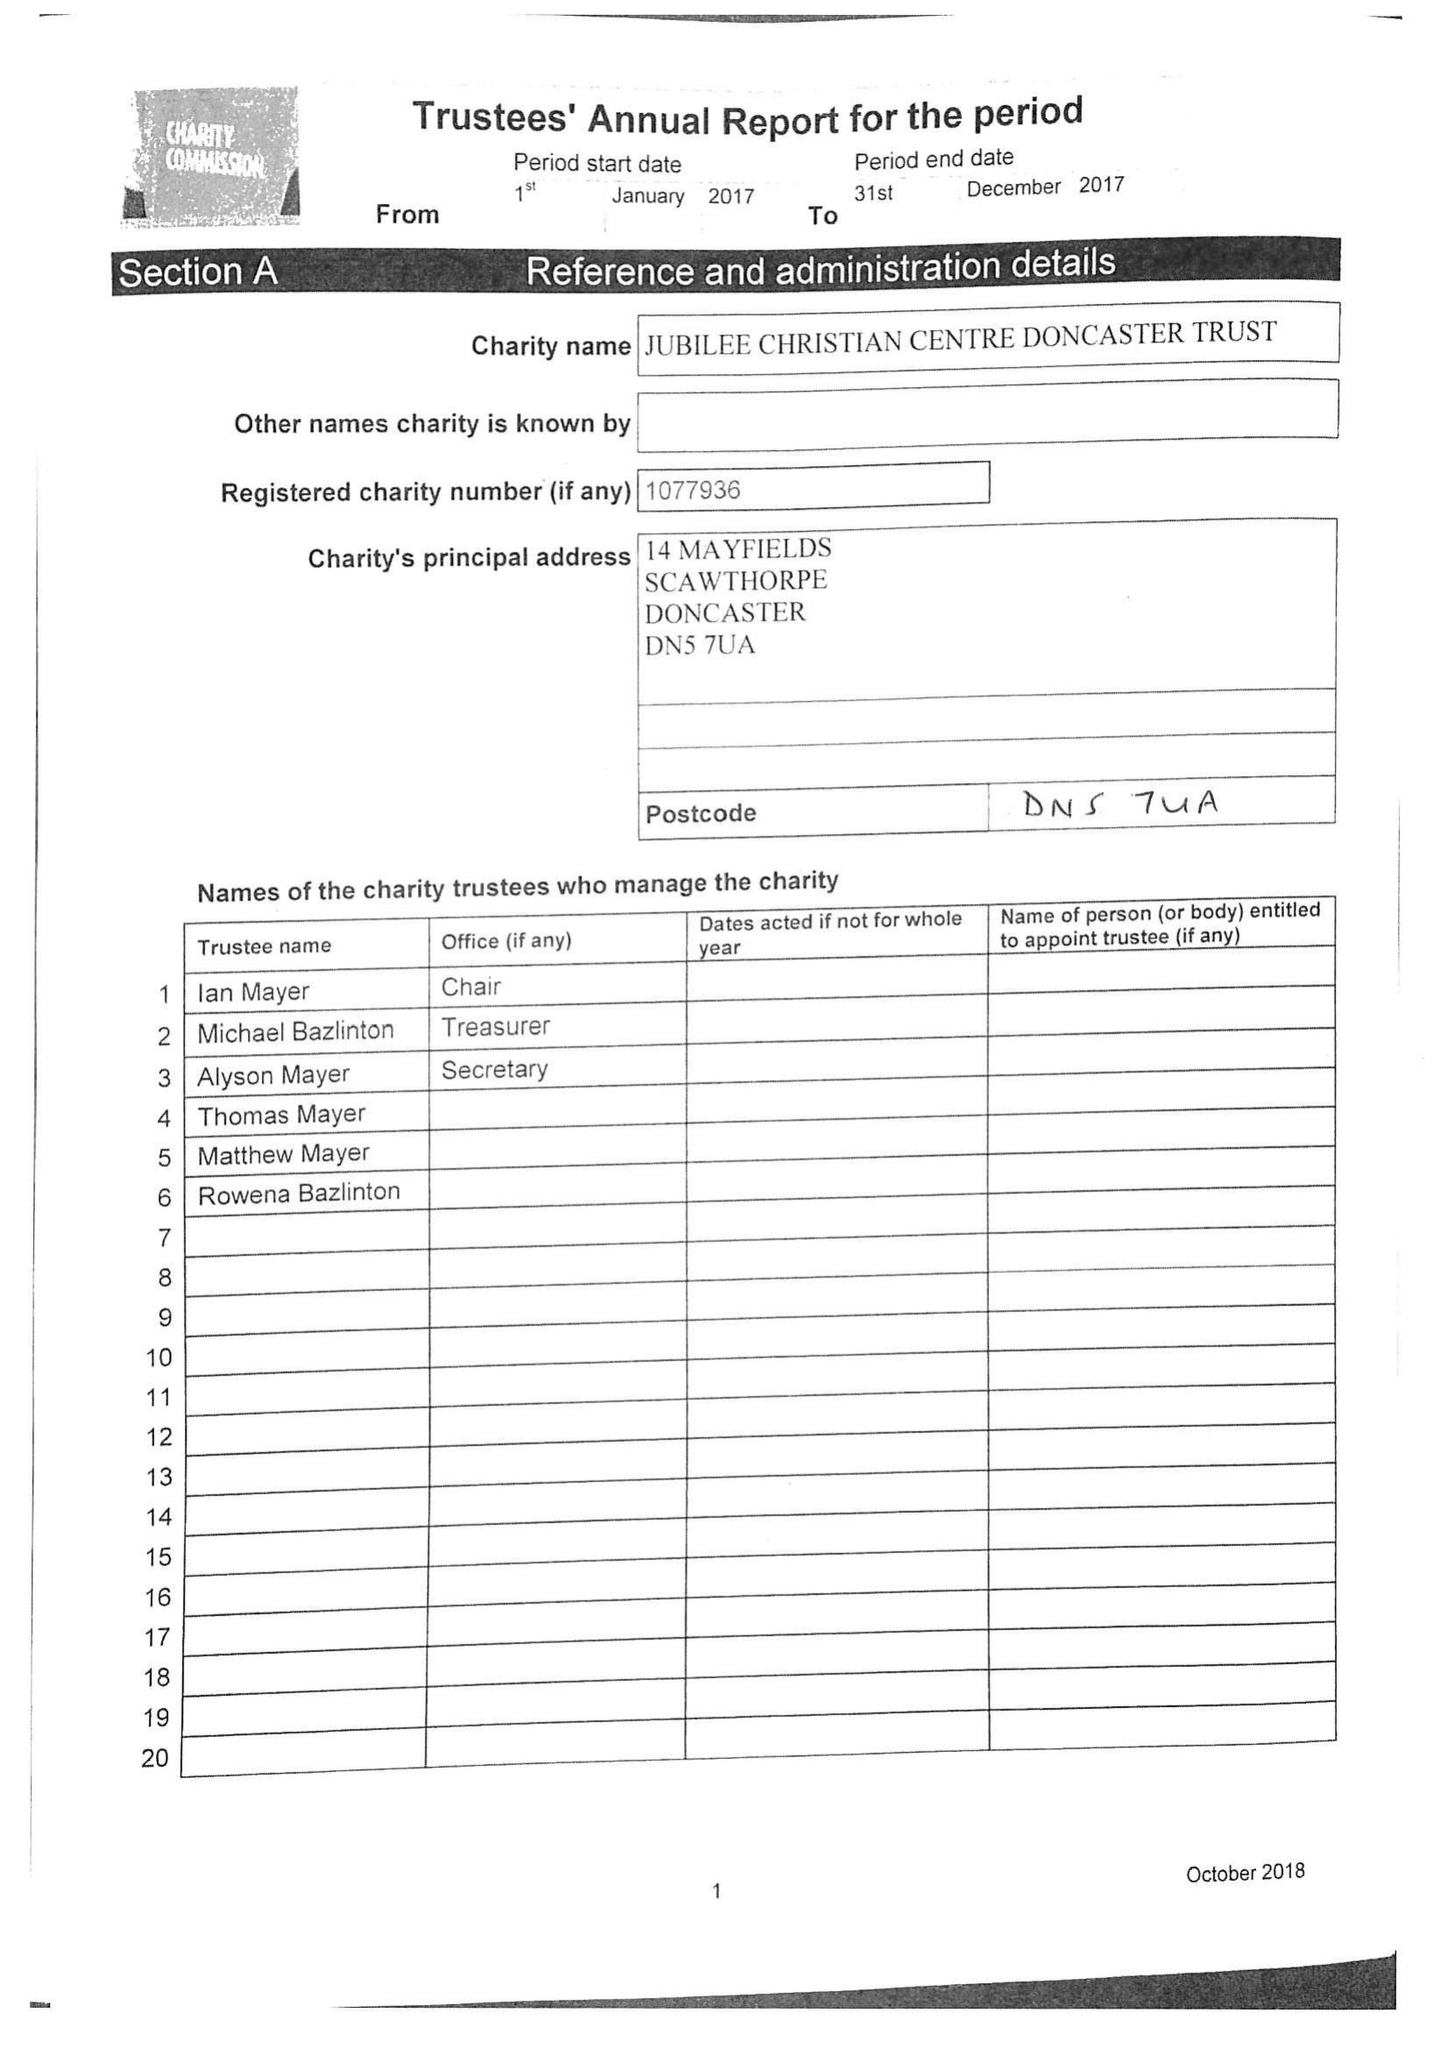What is the value for the address__postcode?
Answer the question using a single word or phrase. DN5 7UA 